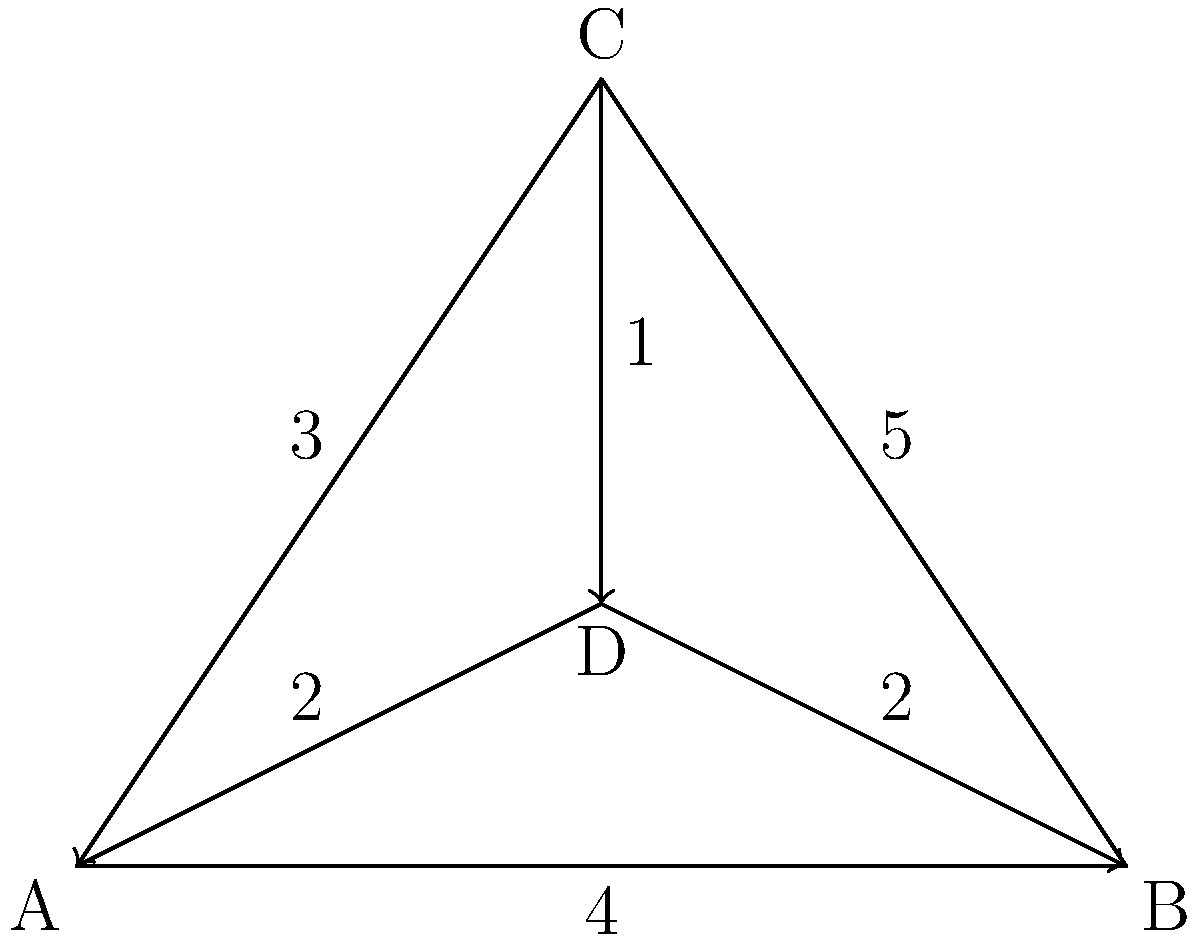In the network diagram representing the load distribution in a Gothic rib vault system, which node has the highest total incoming weight, and what is that weight? To determine the node with the highest total incoming weight, we need to analyze the incoming edges for each node and sum their weights:

1. Node A: No incoming edges, total weight = 0
2. Node B: Incoming edges from A (4) and D (2), total weight = 4 + 2 = 6
3. Node C: Incoming edges from A (3) and B (5), total weight = 3 + 5 = 8
4. Node D: Incoming edges from A (2) and C (1), total weight = 2 + 1 = 3

Comparing the total incoming weights:
A: 0
B: 6
C: 8
D: 3

Node C has the highest total incoming weight of 8.
Answer: Node C, 8 